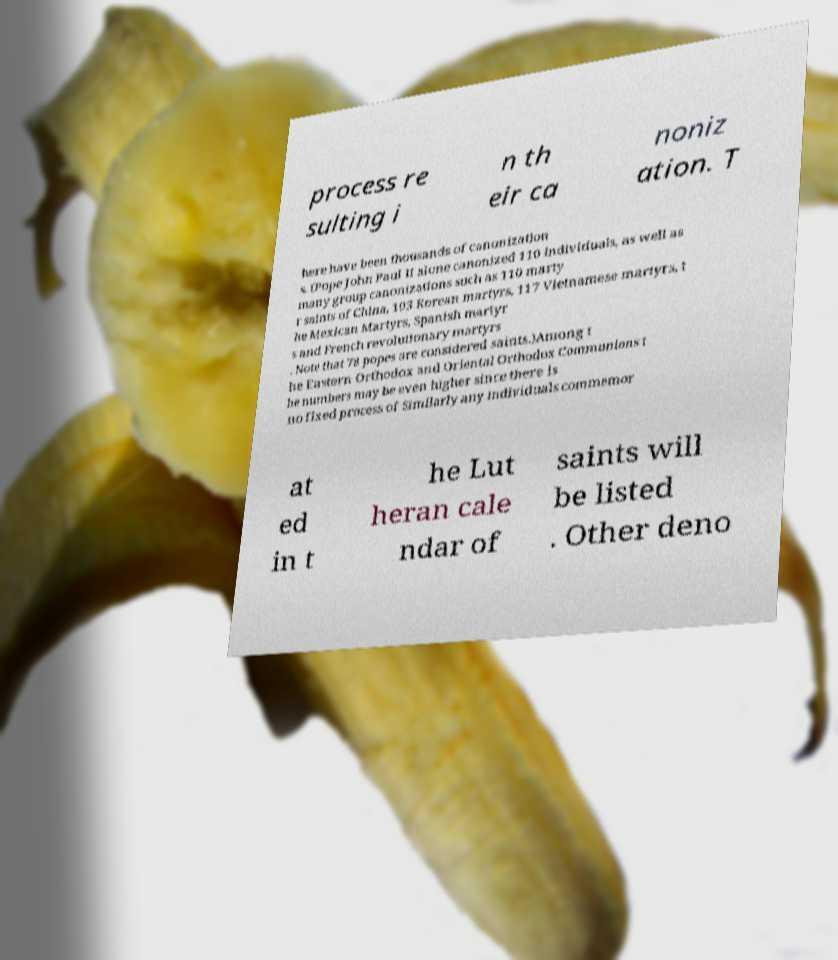Please read and relay the text visible in this image. What does it say? process re sulting i n th eir ca noniz ation. T here have been thousands of canonization s. (Pope John Paul II alone canonized 110 individuals, as well as many group canonizations such as 110 marty r saints of China, 103 Korean martyrs, 117 Vietnamese martyrs, t he Mexican Martyrs, Spanish martyr s and French revolutionary martyrs . Note that 78 popes are considered saints.)Among t he Eastern Orthodox and Oriental Orthodox Communions t he numbers may be even higher since there is no fixed process of Similarly any individuals commemor at ed in t he Lut heran cale ndar of saints will be listed . Other deno 